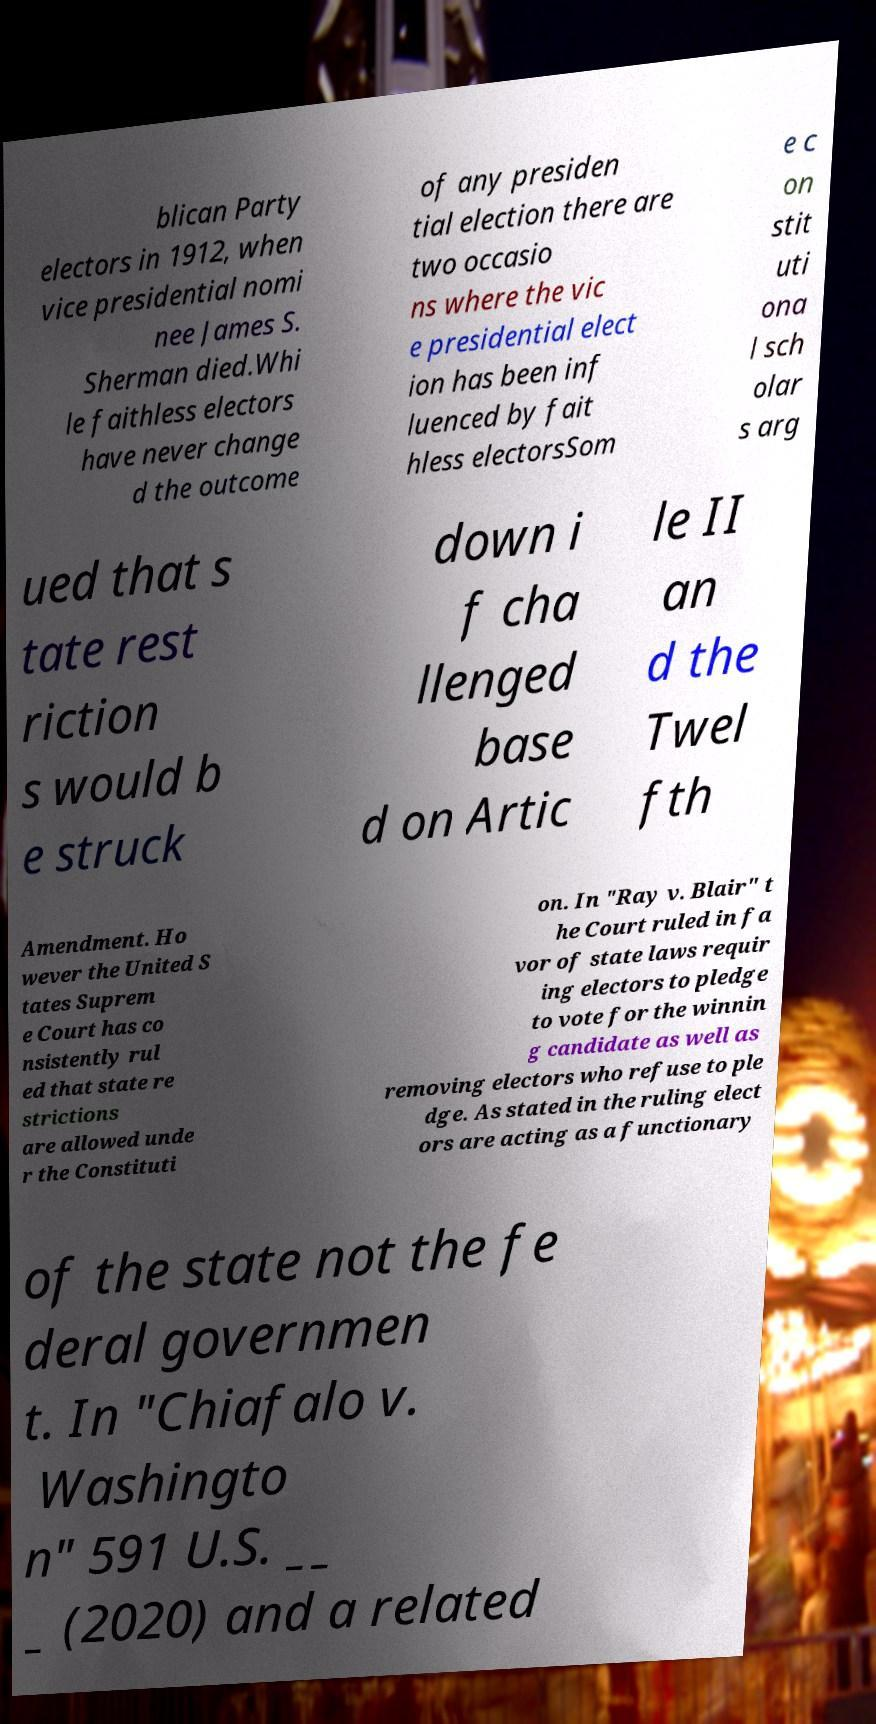What messages or text are displayed in this image? I need them in a readable, typed format. blican Party electors in 1912, when vice presidential nomi nee James S. Sherman died.Whi le faithless electors have never change d the outcome of any presiden tial election there are two occasio ns where the vic e presidential elect ion has been inf luenced by fait hless electorsSom e c on stit uti ona l sch olar s arg ued that s tate rest riction s would b e struck down i f cha llenged base d on Artic le II an d the Twel fth Amendment. Ho wever the United S tates Suprem e Court has co nsistently rul ed that state re strictions are allowed unde r the Constituti on. In "Ray v. Blair" t he Court ruled in fa vor of state laws requir ing electors to pledge to vote for the winnin g candidate as well as removing electors who refuse to ple dge. As stated in the ruling elect ors are acting as a functionary of the state not the fe deral governmen t. In "Chiafalo v. Washingto n" 591 U.S. __ _ (2020) and a related 